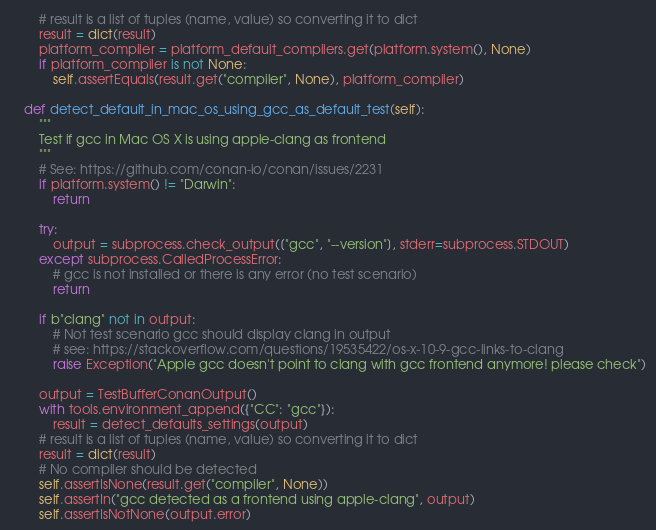Convert code to text. <code><loc_0><loc_0><loc_500><loc_500><_Python_>        # result is a list of tuples (name, value) so converting it to dict
        result = dict(result)
        platform_compiler = platform_default_compilers.get(platform.system(), None)
        if platform_compiler is not None:
            self.assertEquals(result.get("compiler", None), platform_compiler)

    def detect_default_in_mac_os_using_gcc_as_default_test(self):
        """
        Test if gcc in Mac OS X is using apple-clang as frontend
        """
        # See: https://github.com/conan-io/conan/issues/2231
        if platform.system() != "Darwin":
            return

        try:
            output = subprocess.check_output(["gcc", "--version"], stderr=subprocess.STDOUT)
        except subprocess.CalledProcessError:
            # gcc is not installed or there is any error (no test scenario)
            return

        if b"clang" not in output:
            # Not test scenario gcc should display clang in output
            # see: https://stackoverflow.com/questions/19535422/os-x-10-9-gcc-links-to-clang
            raise Exception("Apple gcc doesn't point to clang with gcc frontend anymore! please check")

        output = TestBufferConanOutput()
        with tools.environment_append({"CC": "gcc"}):
            result = detect_defaults_settings(output)
        # result is a list of tuples (name, value) so converting it to dict
        result = dict(result)
        # No compiler should be detected
        self.assertIsNone(result.get("compiler", None))
        self.assertIn("gcc detected as a frontend using apple-clang", output)
        self.assertIsNotNone(output.error)
</code> 